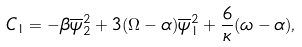Convert formula to latex. <formula><loc_0><loc_0><loc_500><loc_500>C _ { 1 } = - \beta \overline { \psi } _ { 2 } ^ { 2 } + 3 ( \Omega - \alpha ) \overline { \psi } _ { 1 } ^ { 2 } + \frac { 6 } { \kappa } ( \omega - \alpha ) ,</formula> 